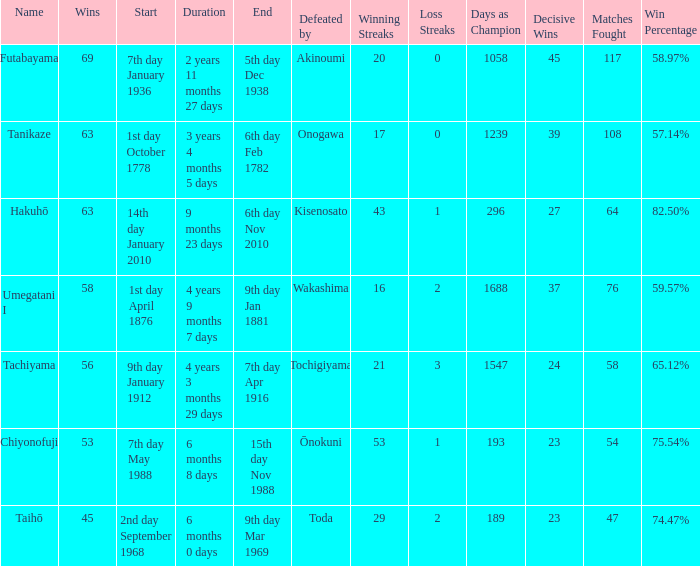How many wins were held before being defeated by toda? 1.0. 